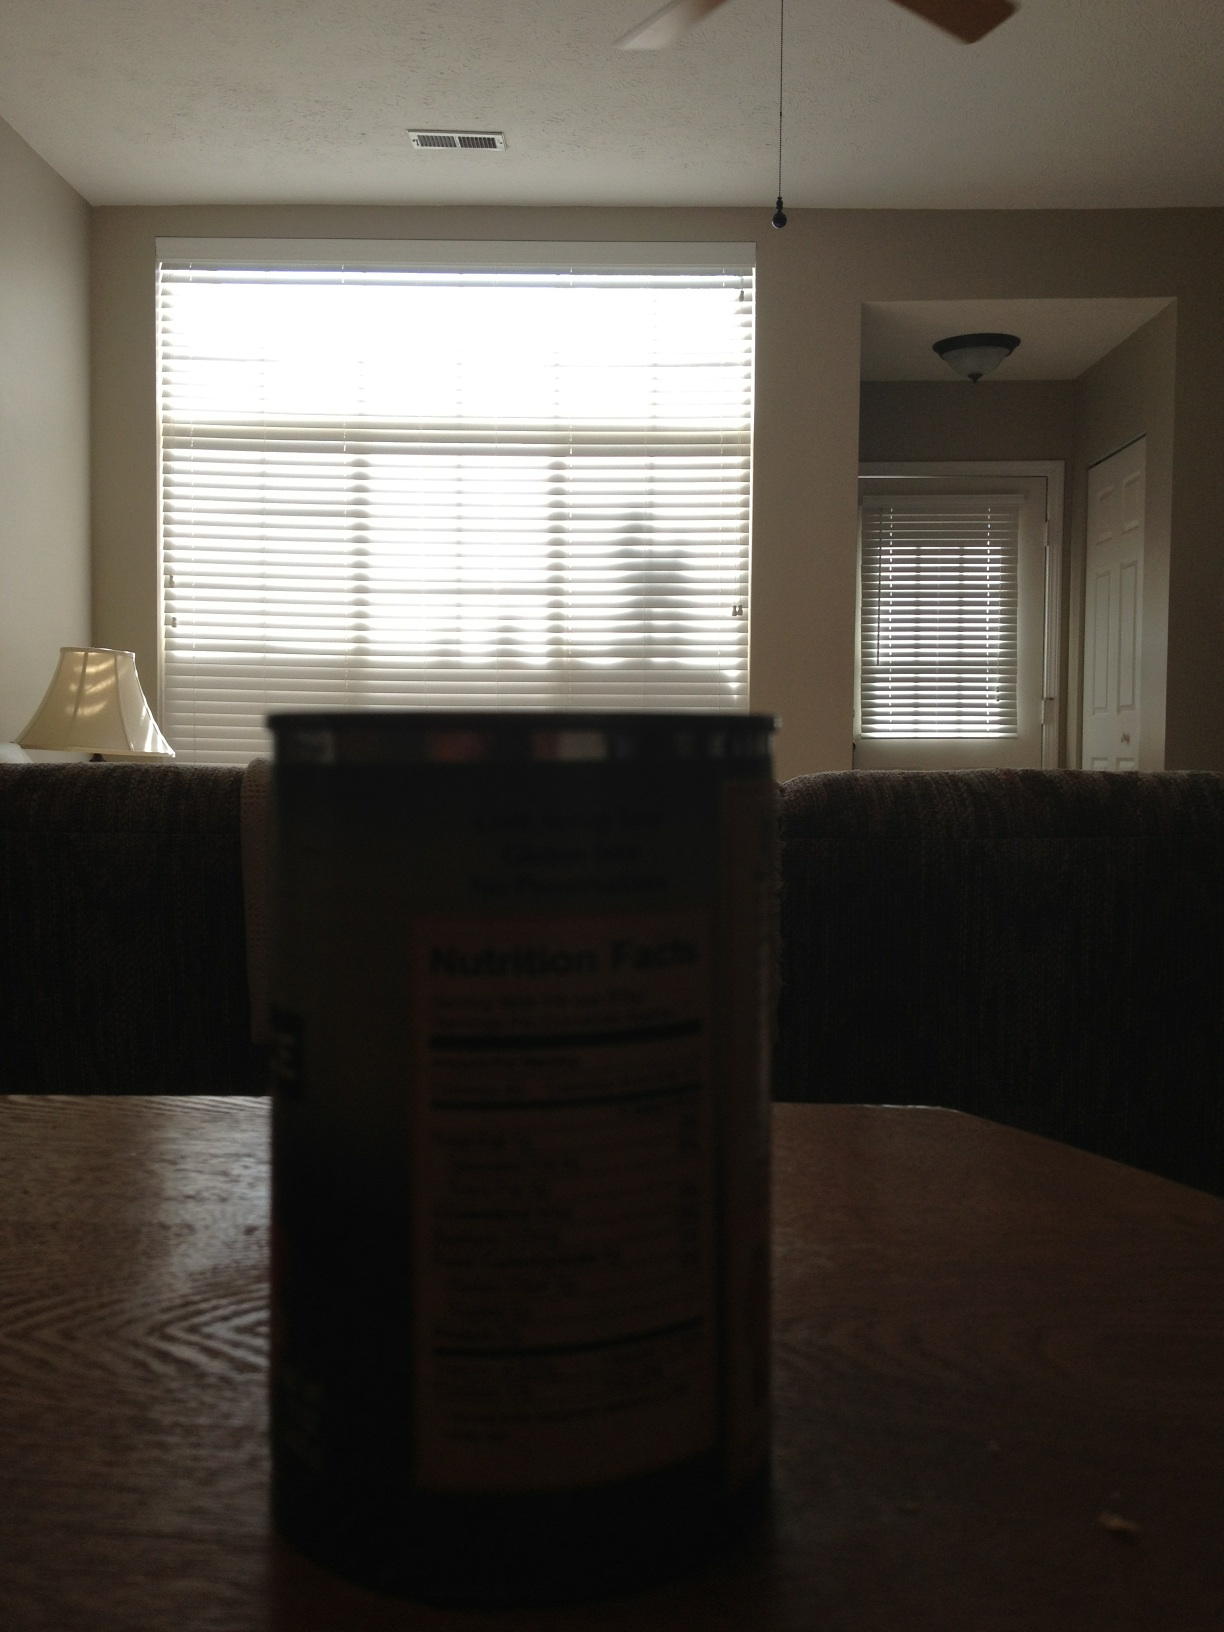Describe the room's lighting and atmosphere. The room has a dim atmosphere, primarily lit by natural light filtering through the window blinds. The soft light contributes to a calm and serene ambiance. 